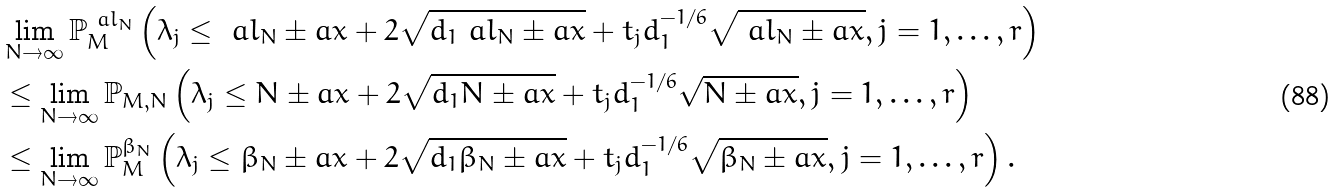<formula> <loc_0><loc_0><loc_500><loc_500>& \lim _ { N \rightarrow \infty } \mathbb { P } _ { M } ^ { \ a l _ { N } } \left ( \lambda _ { j } \leq \ a l _ { N } \pm a x + 2 \sqrt { d _ { 1 } \ a l _ { N } \pm a x } + t _ { j } d _ { 1 } ^ { - 1 / 6 } \sqrt { \ a l _ { N } \pm a x } , j = 1 , \dots , r \right ) \\ & \leq \lim _ { N \rightarrow \infty } \mathbb { P } _ { M , N } \left ( \lambda _ { j } \leq N \pm a x + 2 \sqrt { d _ { 1 } N \pm a x } + t _ { j } d _ { 1 } ^ { - 1 / 6 } \sqrt { N \pm a x } , j = 1 , \dots , r \right ) \\ & \leq \lim _ { N \rightarrow \infty } \mathbb { P } _ { M } ^ { \beta _ { N } } \left ( \lambda _ { j } \leq \beta _ { N } \pm a x + 2 \sqrt { d _ { 1 } \beta _ { N } \pm a x } + t _ { j } d _ { 1 } ^ { - 1 / 6 } \sqrt { \beta _ { N } \pm a x } , j = 1 , \dots , r \right ) .</formula> 